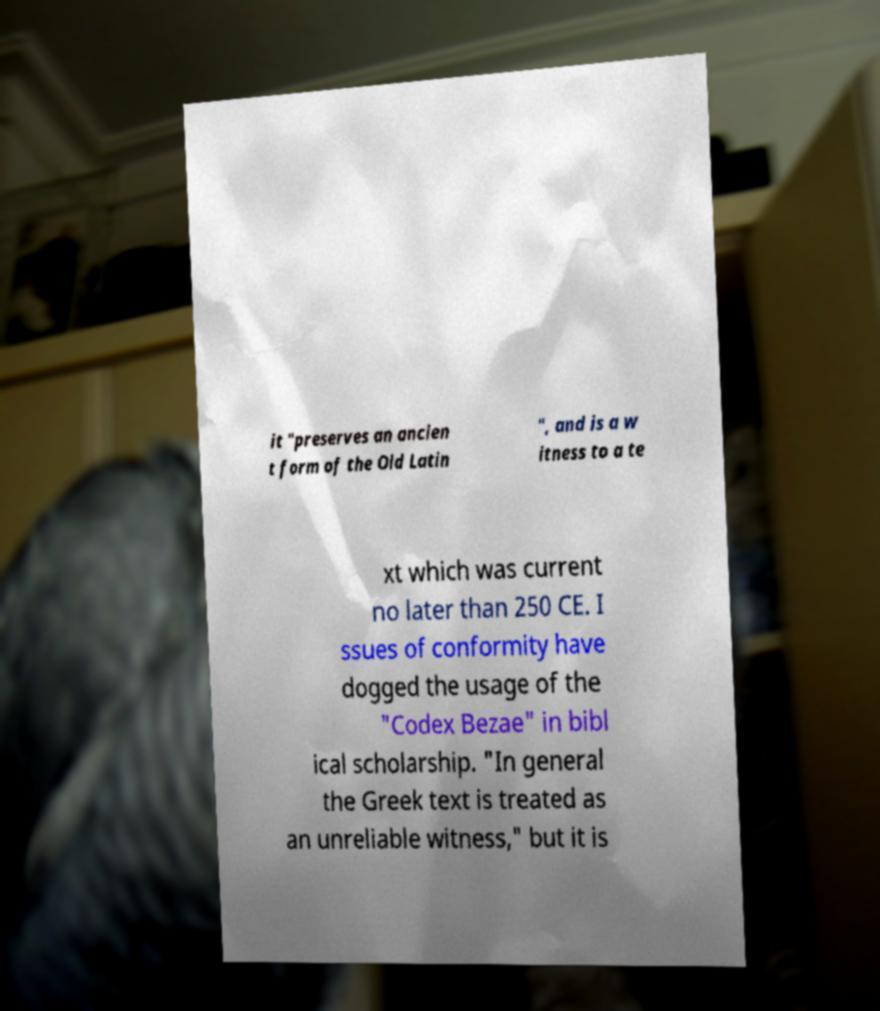Could you assist in decoding the text presented in this image and type it out clearly? it "preserves an ancien t form of the Old Latin ", and is a w itness to a te xt which was current no later than 250 CE. I ssues of conformity have dogged the usage of the "Codex Bezae" in bibl ical scholarship. "In general the Greek text is treated as an unreliable witness," but it is 